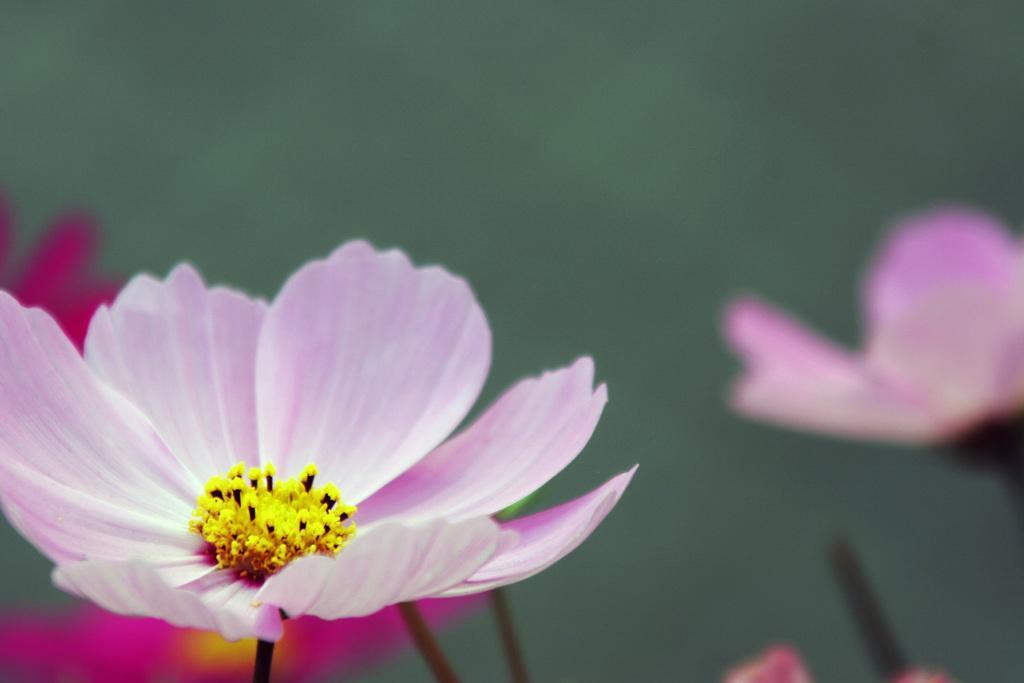Can you describe this image briefly? In this image I can see some flowers to the stems. 